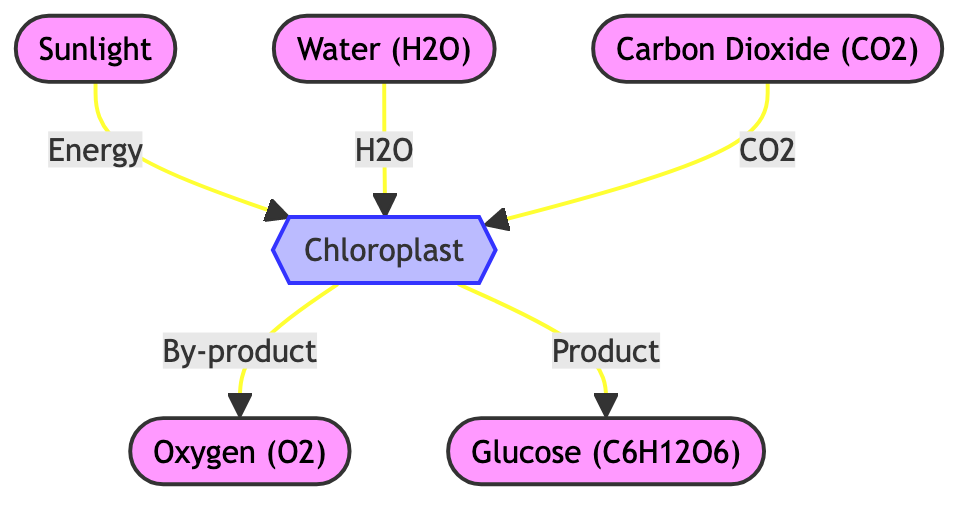What is the main product of photosynthesis shown in the diagram? The main product of photosynthesis in the diagram is located at the node labeled "Glucose (C6H12O6)," which shows that glucose is produced as a result of the process.
Answer: Glucose (C6H12O6) What is released as a by-product during photosynthesis? The diagram indicates that "Oxygen (O2)" is produced as a by-product from the chloroplast after the process of photosynthesis, represented by the flow from the chloroplast to the oxygen node.
Answer: Oxygen (O2) How many nodes are present in the diagram? Count the nodes in the diagram: there are six nodes, including sunlight, chloroplast, water, carbon dioxide, oxygen, and glucose. Therefore, the total number of nodes is six.
Answer: 6 What energy source is required for photosynthesis according to the diagram? The diagram identifies "Sunlight" as the energy source required for the process, indicated by the arrow that directs from "Sunlight" to the "Chloroplast."
Answer: Sunlight Which component is necessary in addition to sunlight for the process carried out in the chloroplast? Besides sunlight, the process also requires "Water (H2O)" as indicated by its direct connection to the chloroplast in the diagram.
Answer: Water (H2O) What is the relationship between carbon dioxide and the chloroplast? The relationship shown in the diagram indicates that "carbon dioxide (CO2)" is taken in by the "chloroplast" as a necessary input for photosynthesis.
Answer: Input Which two inputs are required by the chloroplast? The inputs required by the chloroplast, as shown in the diagram, are "Water (H2O)" and "Carbon Dioxide (CO2)," which both directly flow into the chloroplast.
Answer: Water (H2O) and Carbon Dioxide (CO2) What type of process is represented inside the chloroplast? The diagram categorically shows that the chloroplast conducts a "process" of photosynthesis by converting inputs into outputs, as evidenced by the label on the chloroplast node itself.
Answer: Process How many outputs does the chloroplast produce? The diagram illustrates that the chloroplast produces two outputs: "Oxygen (O2)" and "Glucose (C6H12O6)," indicated by the two arrows leading away from the chloroplast.
Answer: 2 